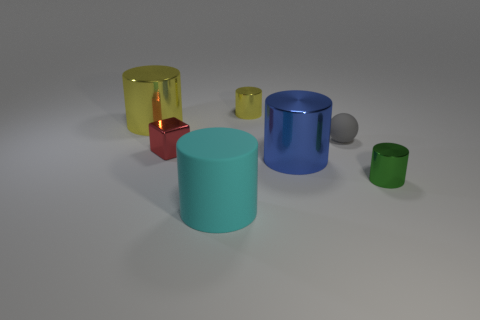What material is the big cyan cylinder that is in front of the gray thing?
Give a very brief answer. Rubber. There is a rubber thing left of the gray matte thing behind the tiny metal cylinder that is to the right of the big blue shiny object; how big is it?
Offer a very short reply. Large. Are the small cylinder that is on the left side of the big blue thing and the big cylinder that is in front of the green metal object made of the same material?
Provide a short and direct response. No. How many other objects are the same color as the ball?
Offer a very short reply. 0. How many things are either tiny shiny cylinders right of the tiny gray sphere or rubber things behind the matte cylinder?
Keep it short and to the point. 2. There is a yellow metal cylinder in front of the tiny shiny cylinder that is to the left of the small green metal thing; what is its size?
Your response must be concise. Large. The cyan matte object has what size?
Your answer should be compact. Large. There is a small cylinder behind the red metal thing; does it have the same color as the big object that is behind the red thing?
Offer a terse response. Yes. What number of other objects are there of the same material as the tiny green thing?
Your response must be concise. 4. Are there any small yellow matte spheres?
Your answer should be very brief. No. 